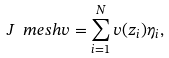<formula> <loc_0><loc_0><loc_500><loc_500>J _ { \ } m e s h v = \sum _ { i = 1 } ^ { N } v ( z _ { i } ) \eta _ { i } ,</formula> 